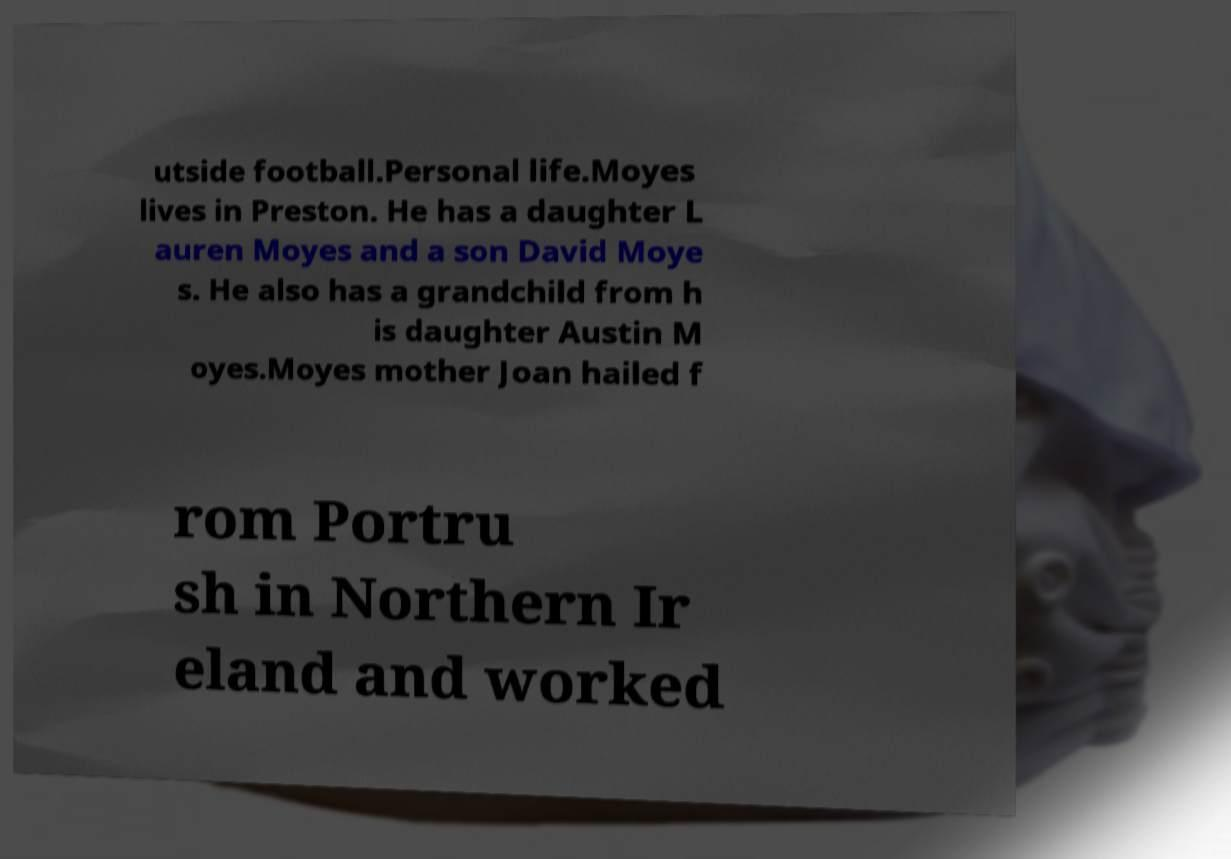Can you read and provide the text displayed in the image?This photo seems to have some interesting text. Can you extract and type it out for me? utside football.Personal life.Moyes lives in Preston. He has a daughter L auren Moyes and a son David Moye s. He also has a grandchild from h is daughter Austin M oyes.Moyes mother Joan hailed f rom Portru sh in Northern Ir eland and worked 